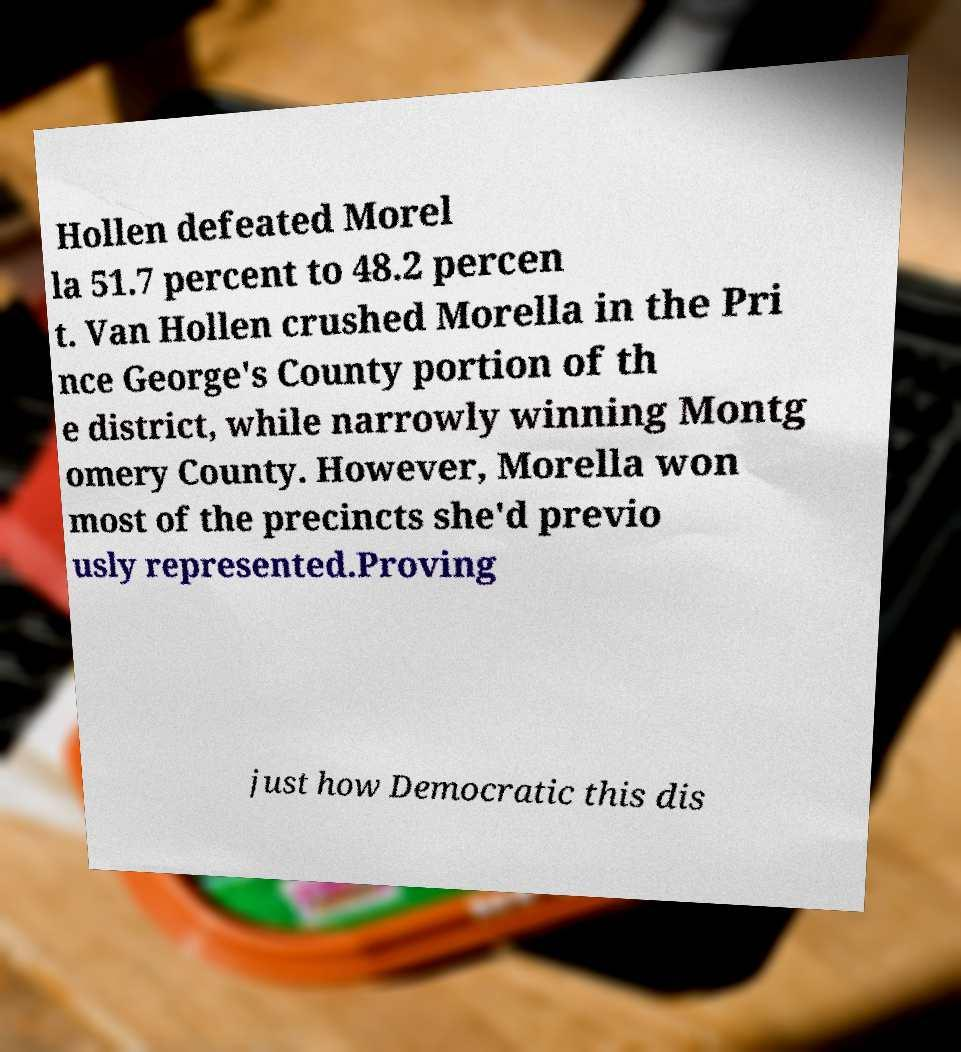What messages or text are displayed in this image? I need them in a readable, typed format. Hollen defeated Morel la 51.7 percent to 48.2 percen t. Van Hollen crushed Morella in the Pri nce George's County portion of th e district, while narrowly winning Montg omery County. However, Morella won most of the precincts she'd previo usly represented.Proving just how Democratic this dis 